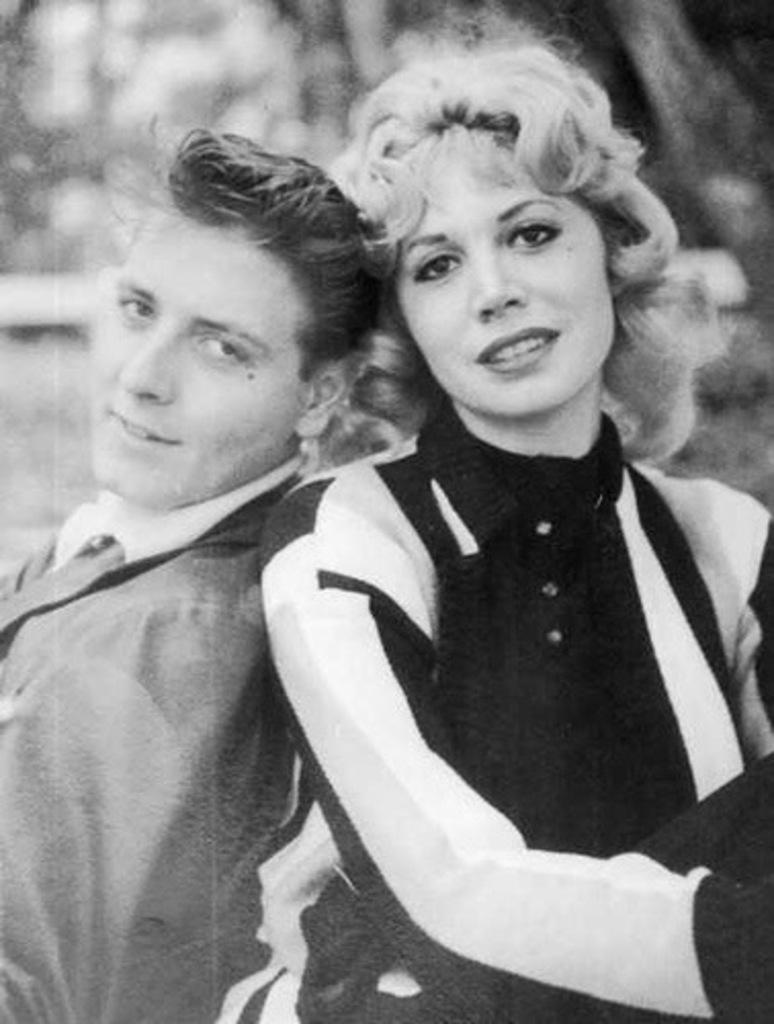How would you summarize this image in a sentence or two? In this image there are two people. On the right there is a lady. On the left we can see a man. 